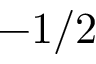<formula> <loc_0><loc_0><loc_500><loc_500>- 1 / 2</formula> 